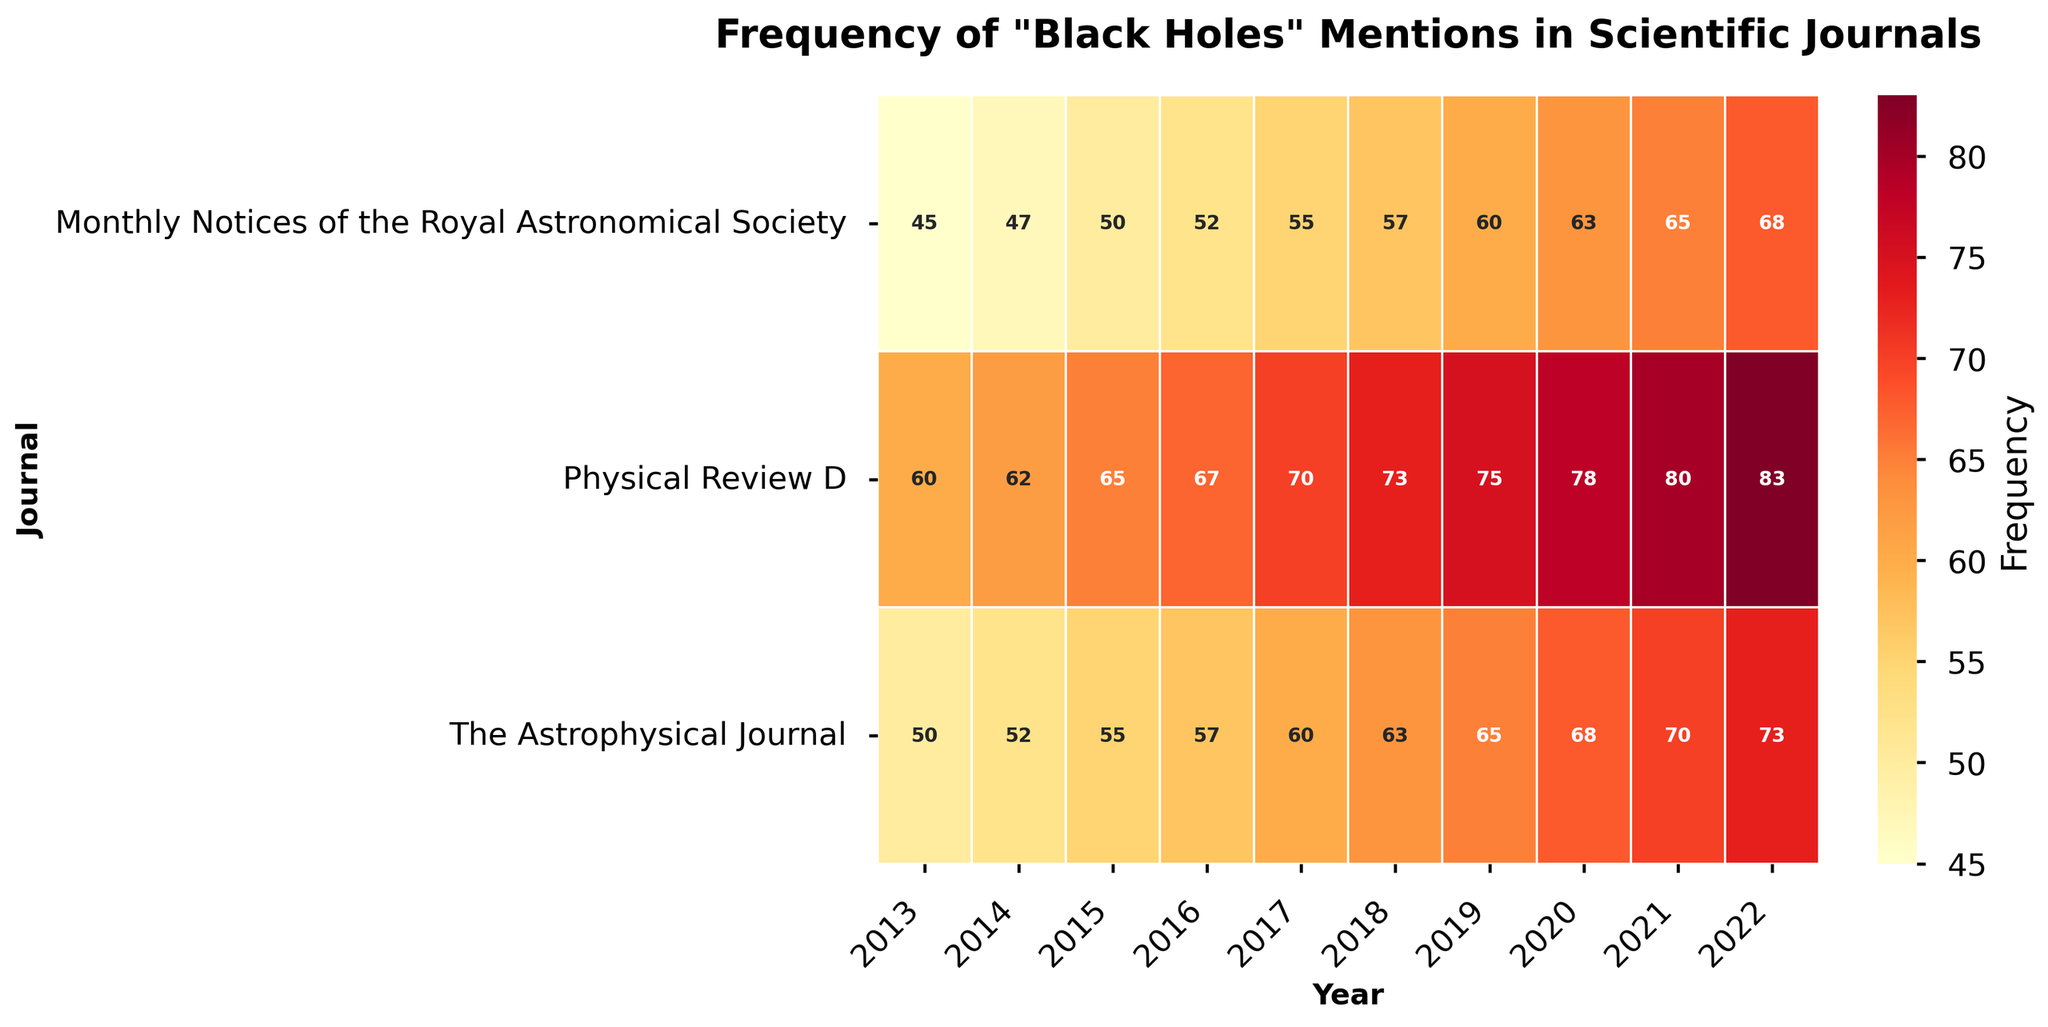What is the title of the heatmap? The title can be seen at the top of the figure. It reads "Frequency of 'Black Holes' Mentions in Scientific Journals".
Answer: Frequency of "Black Holes" Mentions in Scientific Journals Which journal mentioned "Black Holes" the most in 2013? Look at the column for the year 2013 and find the highest value in that column across all rows (journals).
Answer: Physical Review D How many times was "Black Holes" mentioned in The Astrophysical Journal in 2020 compared to 2013? Check the values for The Astrophysical Journal in the columns labeled 2020 and 2013 respectively. Perform the subtraction (68 - 50).
Answer: 18 Which year observed the lowest frequency of "Black Holes" mentions in the Monthly Notices of the Royal Astronomical Society? Identify the smallest number in the row for Monthly Notices of the Royal Astronomical Society.
Answer: 2013 What is the overall trend in the frequency of "Black Holes" mentions in the Physical Review D journal over the decade? Observe the values in the row for Physical Review D from 2013 to 2022. The numbers gradually increase from 60 to 83.
Answer: Increasing How does the 2022 frequency of "Black Holes" mentions in the Monthly Notices of the Royal Astronomical Society compare to the same year in The Astrophysical Journal? Compare the values for the year 2022 in both journals. The Monthly Notices is 68, whereas The Astrophysical Journal is 73.
Answer: The Astrophysical Journal is higher On average, how many times per year was "Black Holes" mentioned in the Monthly Notices of the Royal Astronomical Society? Sum the values for all years (45 + 47 + 50 + 52 + 55 + 57 + 60 + 63 + 65 + 68) and divide by the number of years (10). (582 / 10 = 58.2)
Answer: 58.2 In which journal and year was the highest mention of "Black Holes" recorded and what is the frequency? Identify the highest cell value in the heatmap, which is 83 for the year 2022 in Physical Review D.
Answer: Physical Review D, 2022, 83 How much did the mentions of "Black Holes" increase in Physical Review D from 2013 to 2022? Subtract the 2013 value from the 2022 value for Physical Review D (83 - 60).
Answer: 23 